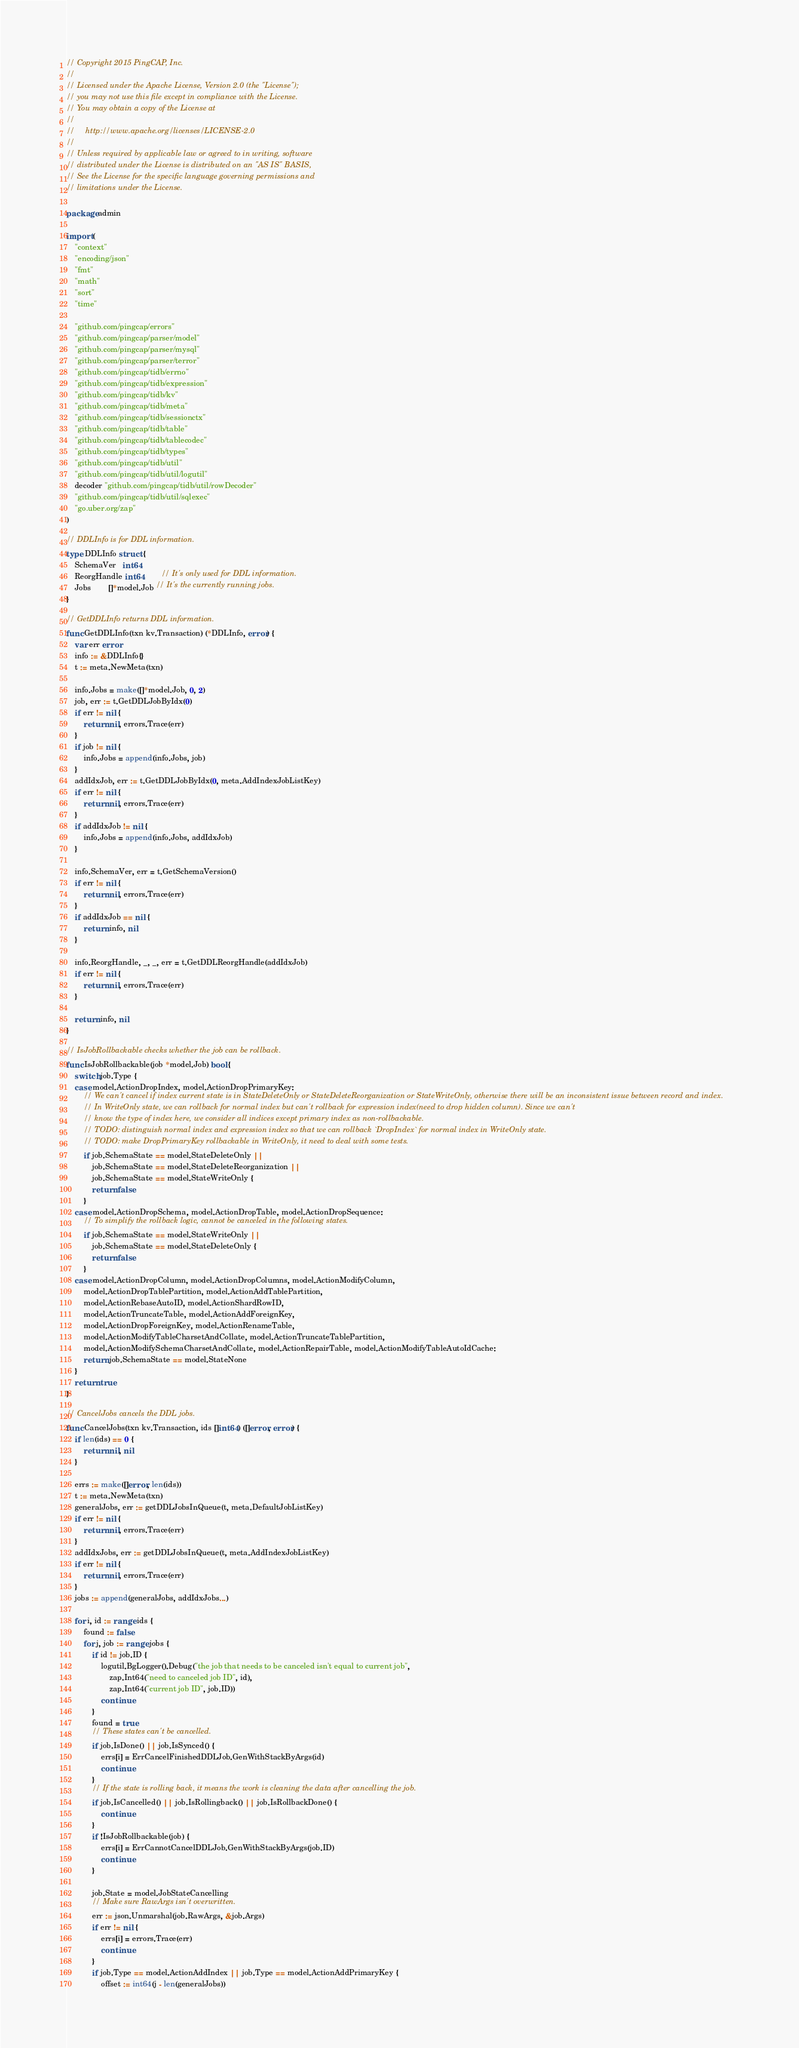<code> <loc_0><loc_0><loc_500><loc_500><_Go_>// Copyright 2015 PingCAP, Inc.
//
// Licensed under the Apache License, Version 2.0 (the "License");
// you may not use this file except in compliance with the License.
// You may obtain a copy of the License at
//
//     http://www.apache.org/licenses/LICENSE-2.0
//
// Unless required by applicable law or agreed to in writing, software
// distributed under the License is distributed on an "AS IS" BASIS,
// See the License for the specific language governing permissions and
// limitations under the License.

package admin

import (
	"context"
	"encoding/json"
	"fmt"
	"math"
	"sort"
	"time"

	"github.com/pingcap/errors"
	"github.com/pingcap/parser/model"
	"github.com/pingcap/parser/mysql"
	"github.com/pingcap/parser/terror"
	"github.com/pingcap/tidb/errno"
	"github.com/pingcap/tidb/expression"
	"github.com/pingcap/tidb/kv"
	"github.com/pingcap/tidb/meta"
	"github.com/pingcap/tidb/sessionctx"
	"github.com/pingcap/tidb/table"
	"github.com/pingcap/tidb/tablecodec"
	"github.com/pingcap/tidb/types"
	"github.com/pingcap/tidb/util"
	"github.com/pingcap/tidb/util/logutil"
	decoder "github.com/pingcap/tidb/util/rowDecoder"
	"github.com/pingcap/tidb/util/sqlexec"
	"go.uber.org/zap"
)

// DDLInfo is for DDL information.
type DDLInfo struct {
	SchemaVer   int64
	ReorgHandle int64        // It's only used for DDL information.
	Jobs        []*model.Job // It's the currently running jobs.
}

// GetDDLInfo returns DDL information.
func GetDDLInfo(txn kv.Transaction) (*DDLInfo, error) {
	var err error
	info := &DDLInfo{}
	t := meta.NewMeta(txn)

	info.Jobs = make([]*model.Job, 0, 2)
	job, err := t.GetDDLJobByIdx(0)
	if err != nil {
		return nil, errors.Trace(err)
	}
	if job != nil {
		info.Jobs = append(info.Jobs, job)
	}
	addIdxJob, err := t.GetDDLJobByIdx(0, meta.AddIndexJobListKey)
	if err != nil {
		return nil, errors.Trace(err)
	}
	if addIdxJob != nil {
		info.Jobs = append(info.Jobs, addIdxJob)
	}

	info.SchemaVer, err = t.GetSchemaVersion()
	if err != nil {
		return nil, errors.Trace(err)
	}
	if addIdxJob == nil {
		return info, nil
	}

	info.ReorgHandle, _, _, err = t.GetDDLReorgHandle(addIdxJob)
	if err != nil {
		return nil, errors.Trace(err)
	}

	return info, nil
}

// IsJobRollbackable checks whether the job can be rollback.
func IsJobRollbackable(job *model.Job) bool {
	switch job.Type {
	case model.ActionDropIndex, model.ActionDropPrimaryKey:
		// We can't cancel if index current state is in StateDeleteOnly or StateDeleteReorganization or StateWriteOnly, otherwise there will be an inconsistent issue between record and index.
		// In WriteOnly state, we can rollback for normal index but can't rollback for expression index(need to drop hidden column). Since we can't
		// know the type of index here, we consider all indices except primary index as non-rollbackable.
		// TODO: distinguish normal index and expression index so that we can rollback `DropIndex` for normal index in WriteOnly state.
		// TODO: make DropPrimaryKey rollbackable in WriteOnly, it need to deal with some tests.
		if job.SchemaState == model.StateDeleteOnly ||
			job.SchemaState == model.StateDeleteReorganization ||
			job.SchemaState == model.StateWriteOnly {
			return false
		}
	case model.ActionDropSchema, model.ActionDropTable, model.ActionDropSequence:
		// To simplify the rollback logic, cannot be canceled in the following states.
		if job.SchemaState == model.StateWriteOnly ||
			job.SchemaState == model.StateDeleteOnly {
			return false
		}
	case model.ActionDropColumn, model.ActionDropColumns, model.ActionModifyColumn,
		model.ActionDropTablePartition, model.ActionAddTablePartition,
		model.ActionRebaseAutoID, model.ActionShardRowID,
		model.ActionTruncateTable, model.ActionAddForeignKey,
		model.ActionDropForeignKey, model.ActionRenameTable,
		model.ActionModifyTableCharsetAndCollate, model.ActionTruncateTablePartition,
		model.ActionModifySchemaCharsetAndCollate, model.ActionRepairTable, model.ActionModifyTableAutoIdCache:
		return job.SchemaState == model.StateNone
	}
	return true
}

// CancelJobs cancels the DDL jobs.
func CancelJobs(txn kv.Transaction, ids []int64) ([]error, error) {
	if len(ids) == 0 {
		return nil, nil
	}

	errs := make([]error, len(ids))
	t := meta.NewMeta(txn)
	generalJobs, err := getDDLJobsInQueue(t, meta.DefaultJobListKey)
	if err != nil {
		return nil, errors.Trace(err)
	}
	addIdxJobs, err := getDDLJobsInQueue(t, meta.AddIndexJobListKey)
	if err != nil {
		return nil, errors.Trace(err)
	}
	jobs := append(generalJobs, addIdxJobs...)

	for i, id := range ids {
		found := false
		for j, job := range jobs {
			if id != job.ID {
				logutil.BgLogger().Debug("the job that needs to be canceled isn't equal to current job",
					zap.Int64("need to canceled job ID", id),
					zap.Int64("current job ID", job.ID))
				continue
			}
			found = true
			// These states can't be cancelled.
			if job.IsDone() || job.IsSynced() {
				errs[i] = ErrCancelFinishedDDLJob.GenWithStackByArgs(id)
				continue
			}
			// If the state is rolling back, it means the work is cleaning the data after cancelling the job.
			if job.IsCancelled() || job.IsRollingback() || job.IsRollbackDone() {
				continue
			}
			if !IsJobRollbackable(job) {
				errs[i] = ErrCannotCancelDDLJob.GenWithStackByArgs(job.ID)
				continue
			}

			job.State = model.JobStateCancelling
			// Make sure RawArgs isn't overwritten.
			err := json.Unmarshal(job.RawArgs, &job.Args)
			if err != nil {
				errs[i] = errors.Trace(err)
				continue
			}
			if job.Type == model.ActionAddIndex || job.Type == model.ActionAddPrimaryKey {
				offset := int64(j - len(generalJobs))</code> 